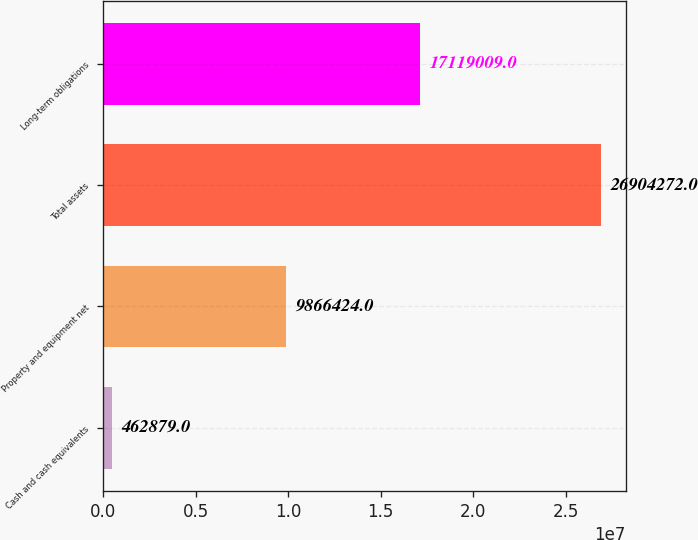Convert chart to OTSL. <chart><loc_0><loc_0><loc_500><loc_500><bar_chart><fcel>Cash and cash equivalents<fcel>Property and equipment net<fcel>Total assets<fcel>Long-term obligations<nl><fcel>462879<fcel>9.86642e+06<fcel>2.69043e+07<fcel>1.7119e+07<nl></chart> 